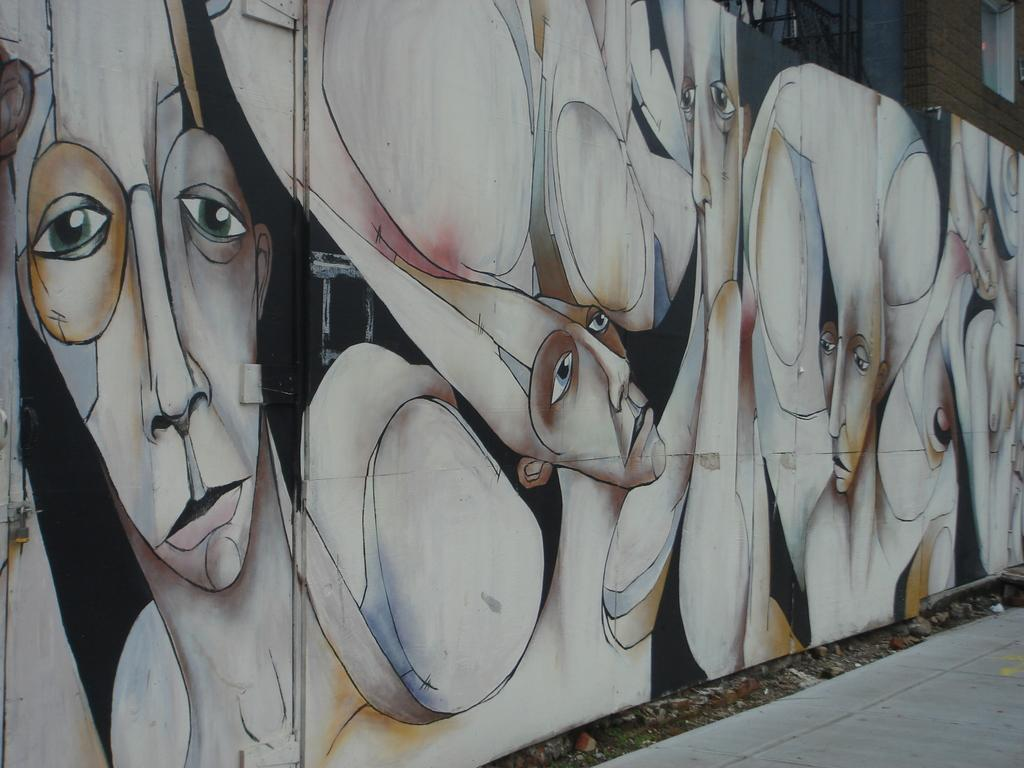What can be seen on the wall in the image? There is graffiti painting on the wall in the image. What type of surface is visible in the bottom right corner of the image? There is a pavement in the right bottom of the image. Where is the window located in the image? There is a window in the right top of the image. Can you tell me how many keys are hanging on the graffiti painting in the image? There are no keys present in the image; it features graffiti painting on a wall. What is the thumb doing in the image? There is no thumb visible in the image. 